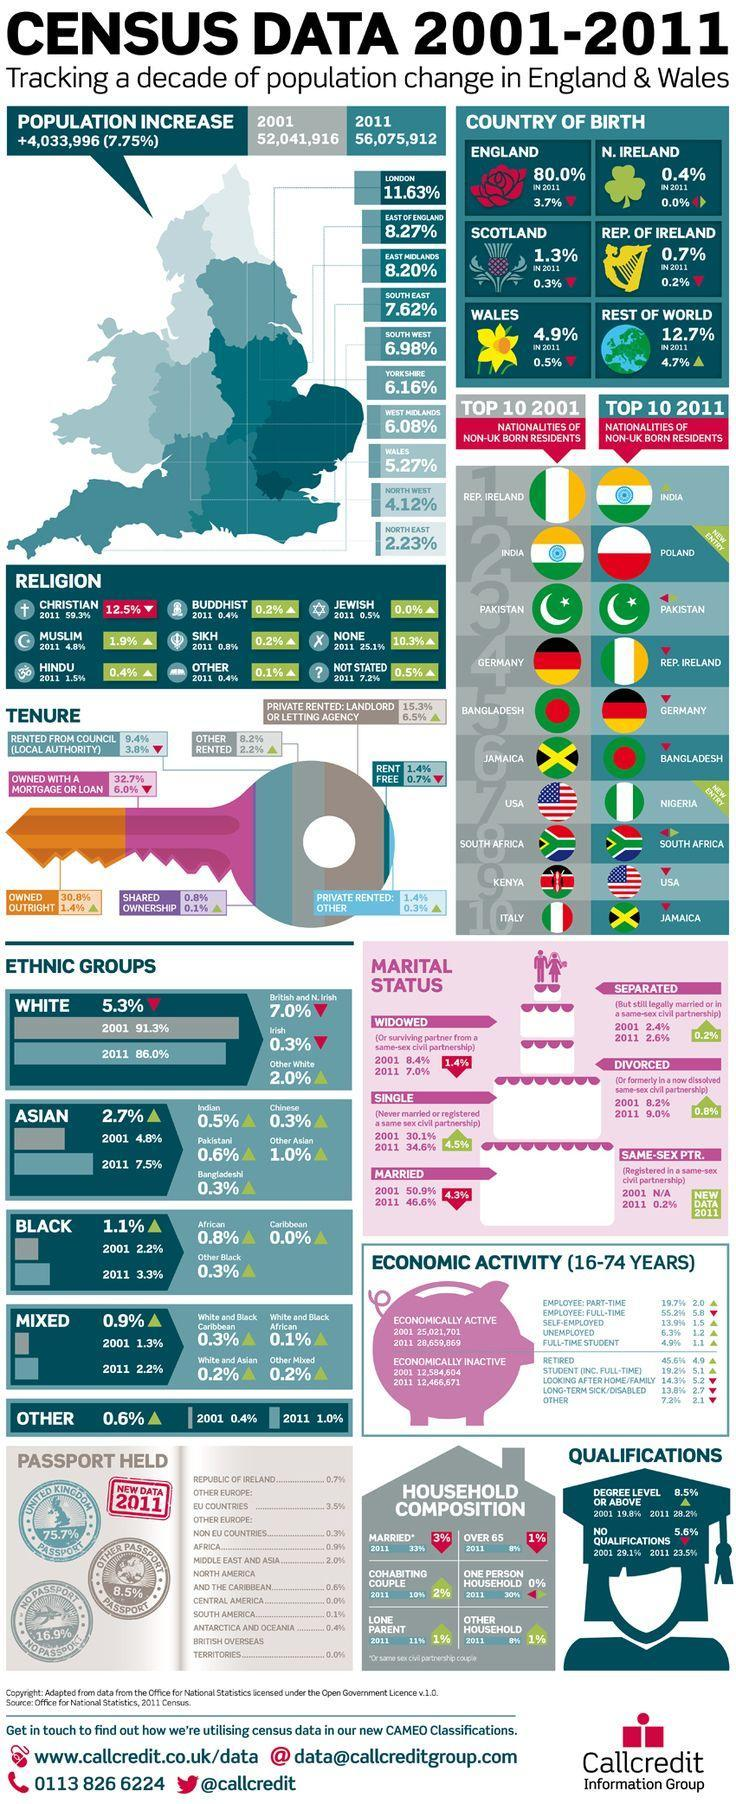What is the percentage of white people in 2001 and 2011, taken together?
Answer the question with a short phrase. 177.3% What is the percentage of Asians in 2001 and 2011, taken together? 12.3% What is the percentage of people whose birth of place is in Wales and the Rest of the World? 17.6% What is the percentage of black people in 2001 and 2011, taken together? 5.5% What is the percentage of people whose birth of place is in England and N.Ireland in 2011? 80.4% What is the percentage of people whose birth of place is in Scotland and Rep. of Ireland in 2011? 2% 